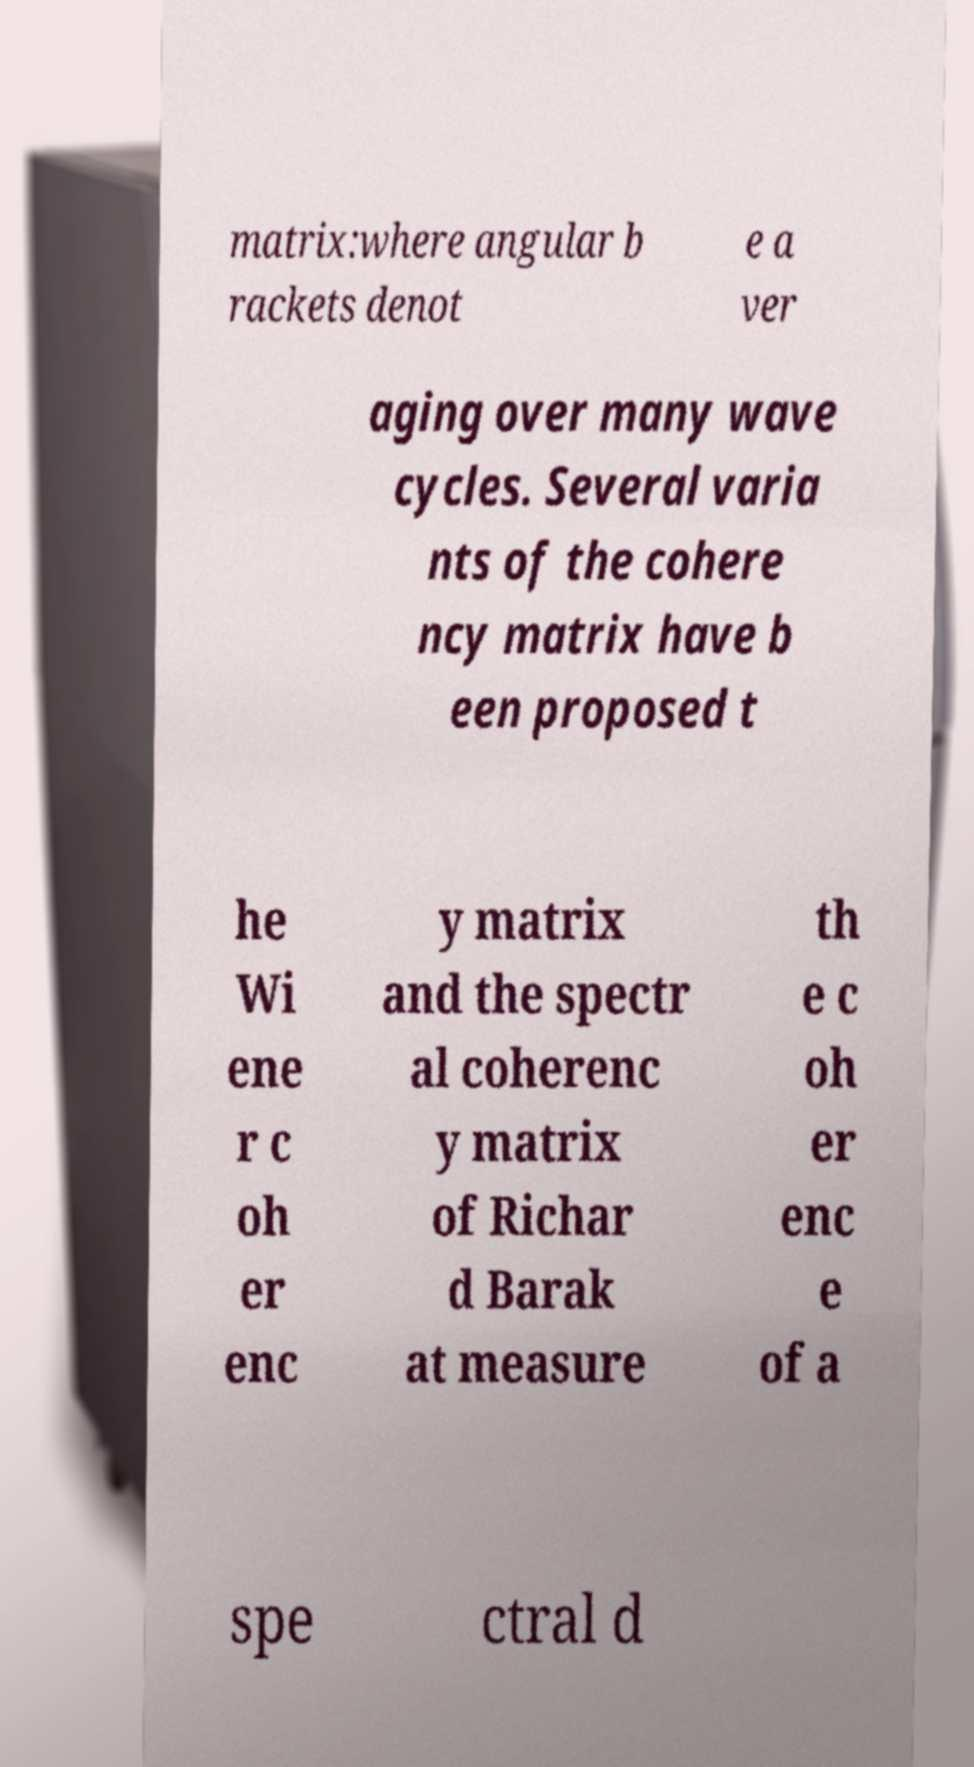Can you accurately transcribe the text from the provided image for me? matrix:where angular b rackets denot e a ver aging over many wave cycles. Several varia nts of the cohere ncy matrix have b een proposed t he Wi ene r c oh er enc y matrix and the spectr al coherenc y matrix of Richar d Barak at measure th e c oh er enc e of a spe ctral d 